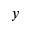Convert formula to latex. <formula><loc_0><loc_0><loc_500><loc_500>y</formula> 